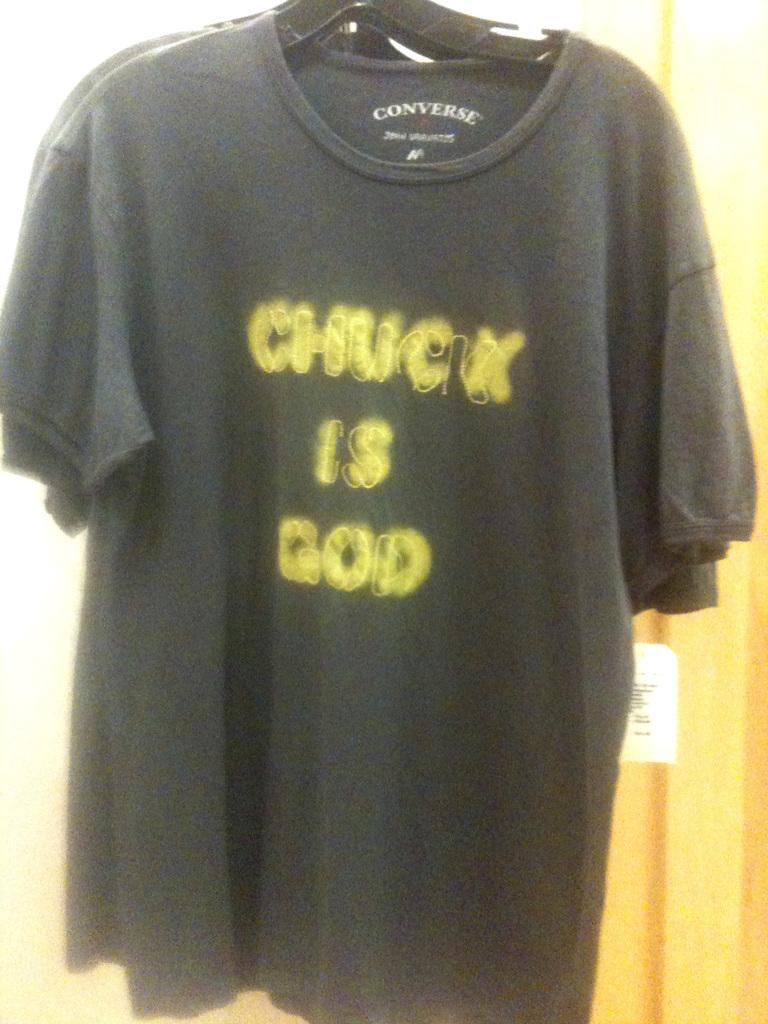What color are the t-shirts in the image? The t-shirts in the image are black. How are the t-shirts arranged in the image? The t-shirts are hanged on a hanger. What type of police equipment can be seen in the image? There is no police equipment present in the image; it features black t-shirts on a hanger. What historical event is depicted in the image? There is no historical event depicted in the image; it features black t-shirts on a hanger. 